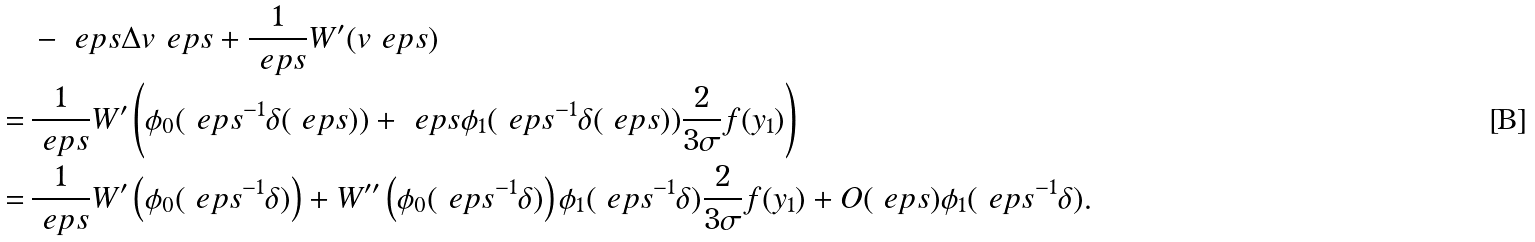Convert formula to latex. <formula><loc_0><loc_0><loc_500><loc_500>& - \ e p s \Delta v _ { \ } e p s + \frac { 1 } { \ e p s } W ^ { \prime } ( v _ { \ } e p s ) \\ = \, & \frac { 1 } { \ e p s } W ^ { \prime } \left ( \phi _ { 0 } ( \ e p s ^ { - 1 } \delta ( \ e p s ) ) + \ e p s \phi _ { 1 } ( \ e p s ^ { - 1 } \delta ( \ e p s ) ) \frac { 2 } { 3 \sigma } f ( y _ { 1 } ) \right ) \\ = \, & \frac { 1 } { \ e p s } W ^ { \prime } \left ( \phi _ { 0 } ( \ e p s ^ { - 1 } \delta ) \right ) + W ^ { \prime \prime } \left ( \phi _ { 0 } ( \ e p s ^ { - 1 } \delta ) \right ) \phi _ { 1 } ( \ e p s ^ { - 1 } \delta ) \frac { 2 } { 3 \sigma } f ( y _ { 1 } ) + O ( \ e p s ) \phi _ { 1 } ( \ e p s ^ { - 1 } \delta ) .</formula> 